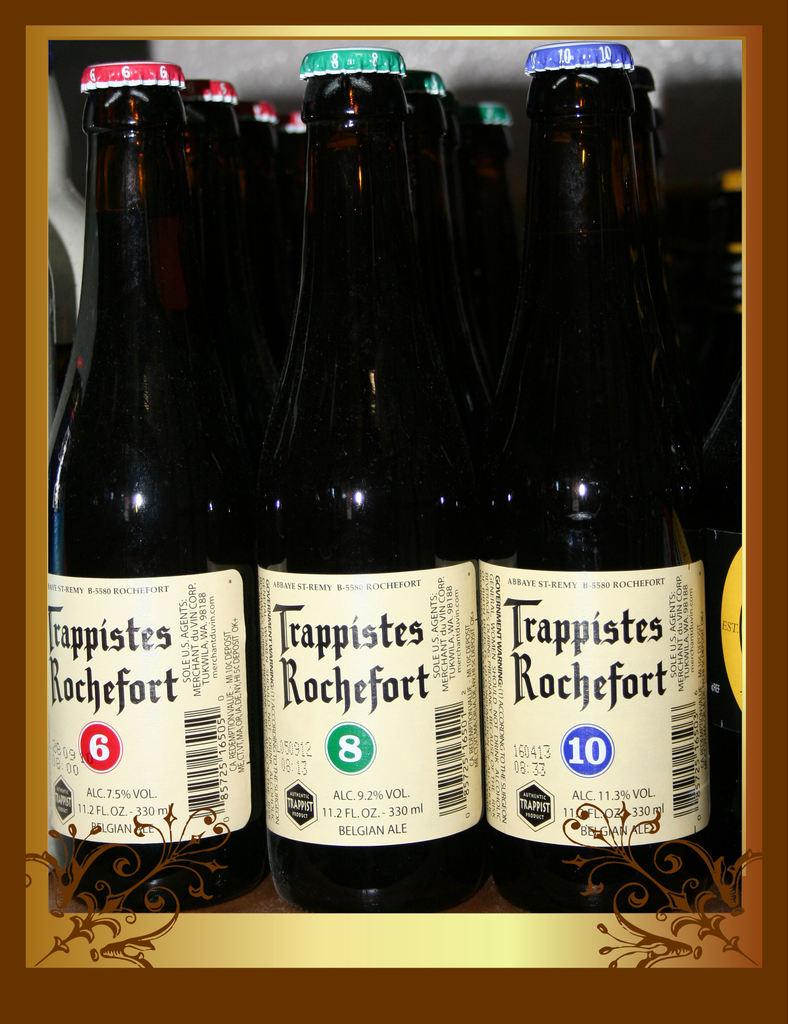What is the alcoholic content of the middle bottle?
Provide a succinct answer. 9.2%. 